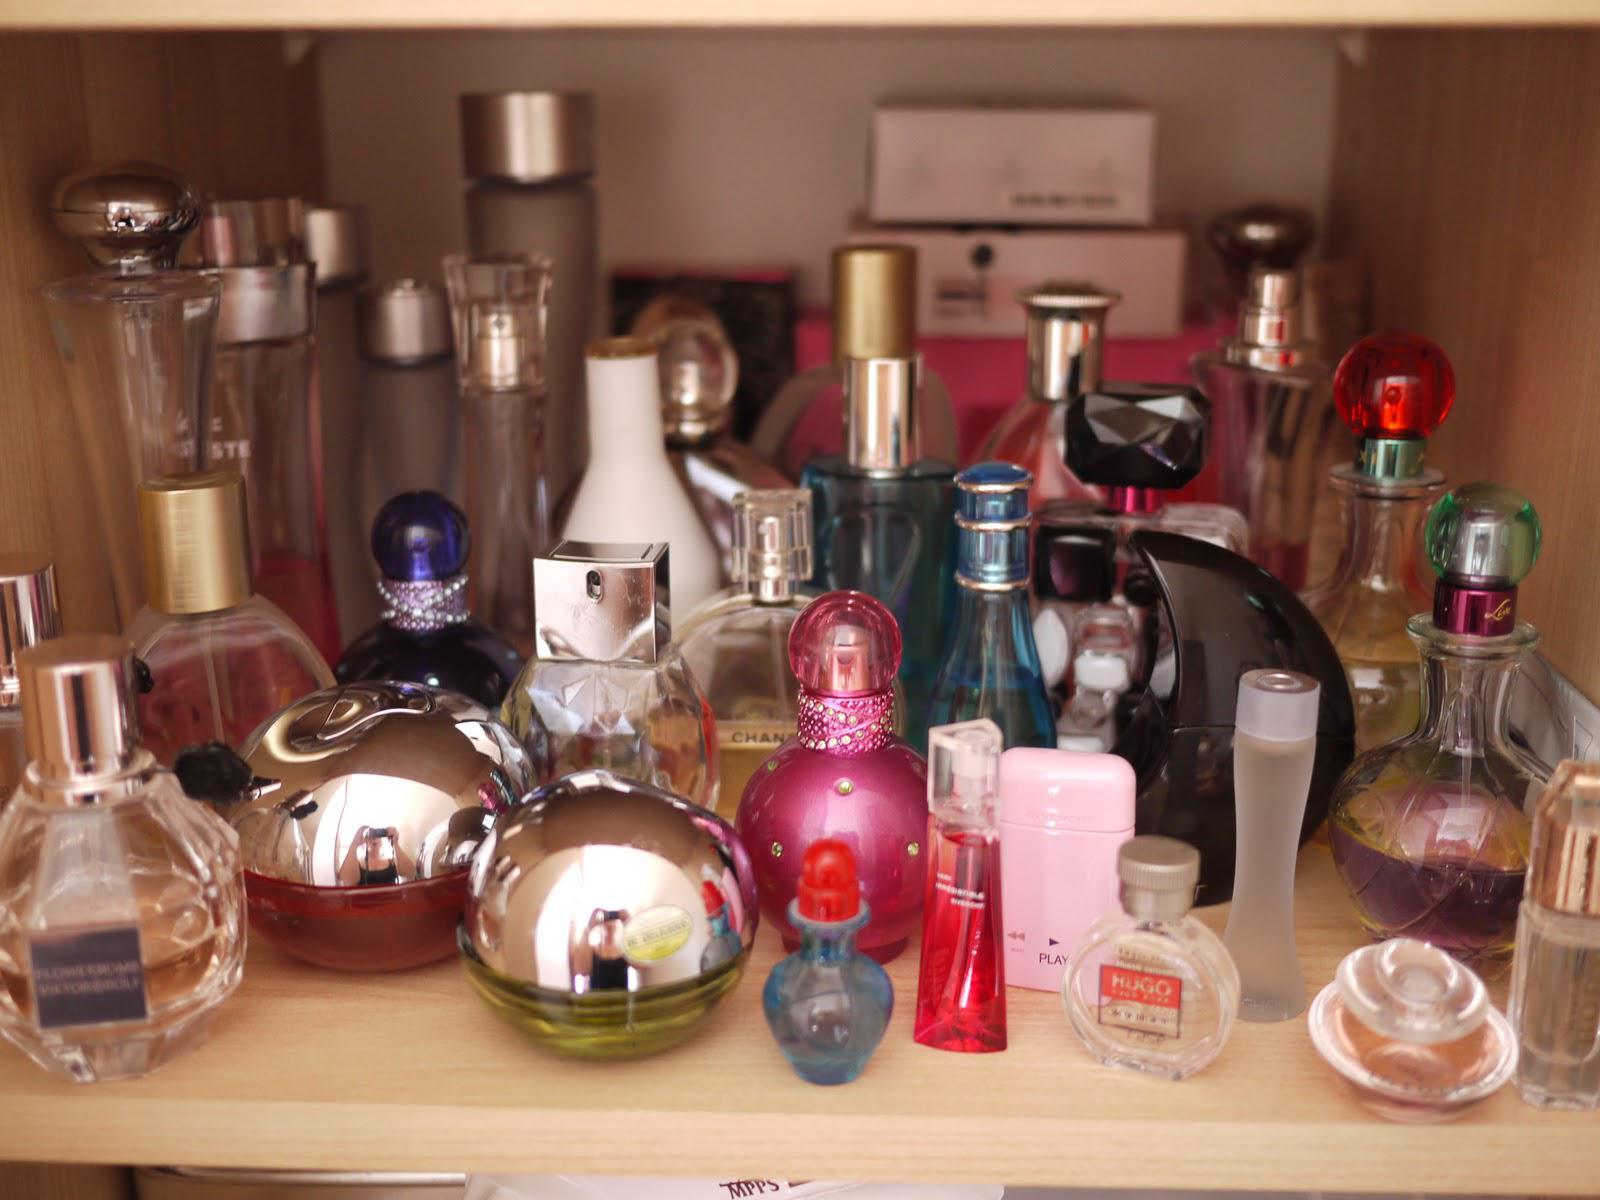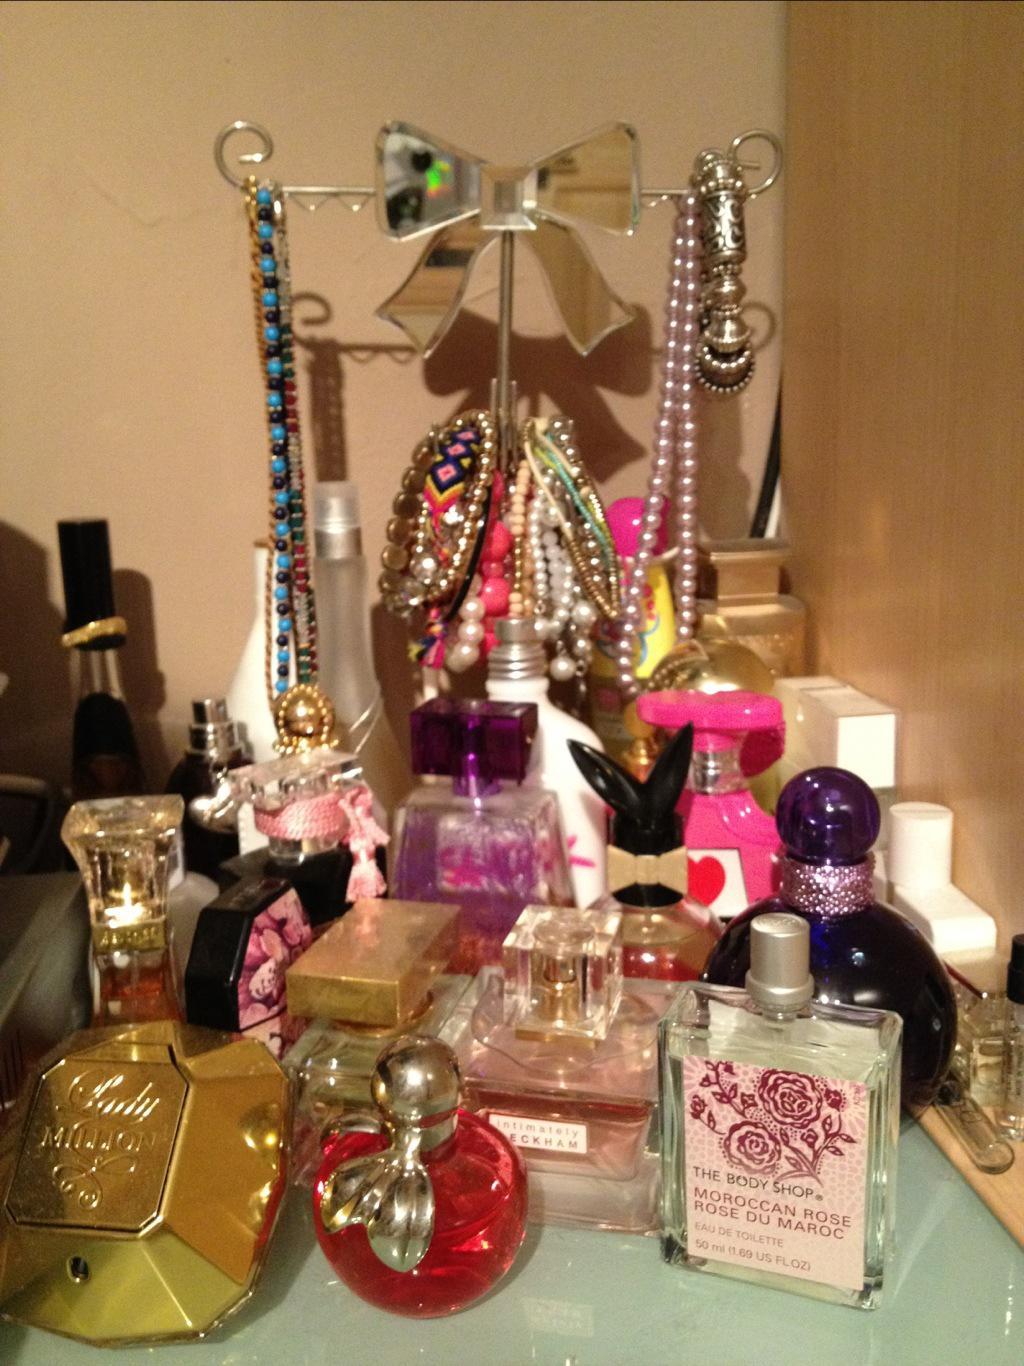The first image is the image on the left, the second image is the image on the right. For the images displayed, is the sentence "A heart-shaped clear glass bottle is in the front of a grouping of different fragrance bottles." factually correct? Answer yes or no. No. The first image is the image on the left, the second image is the image on the right. Considering the images on both sides, is "Every image has more than nine fragrances." valid? Answer yes or no. Yes. 